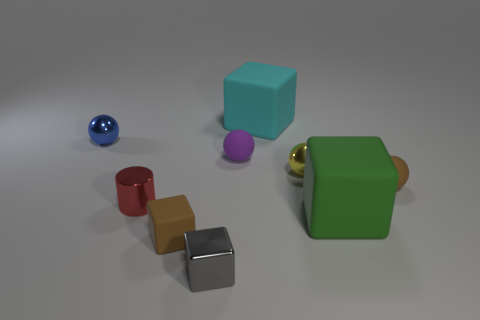Subtract all small purple spheres. How many spheres are left? 3 Subtract all cyan blocks. How many blocks are left? 3 Add 1 purple shiny cylinders. How many objects exist? 10 Subtract all blocks. How many objects are left? 5 Subtract 2 spheres. How many spheres are left? 2 Add 8 small yellow things. How many small yellow things are left? 9 Add 6 cyan matte things. How many cyan matte things exist? 7 Subtract 1 brown balls. How many objects are left? 8 Subtract all brown blocks. Subtract all yellow balls. How many blocks are left? 3 Subtract all cyan balls. How many brown cylinders are left? 0 